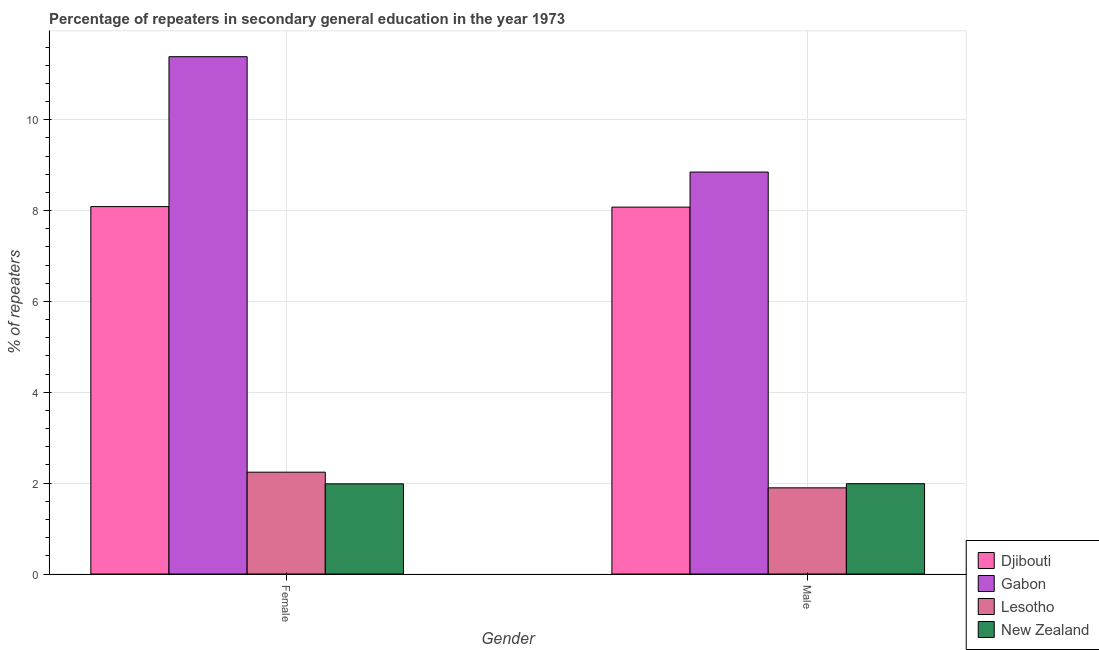How many groups of bars are there?
Keep it short and to the point. 2. Are the number of bars on each tick of the X-axis equal?
Make the answer very short. Yes. How many bars are there on the 1st tick from the left?
Your response must be concise. 4. What is the percentage of male repeaters in New Zealand?
Provide a short and direct response. 1.99. Across all countries, what is the maximum percentage of male repeaters?
Provide a succinct answer. 8.85. Across all countries, what is the minimum percentage of male repeaters?
Ensure brevity in your answer.  1.9. In which country was the percentage of female repeaters maximum?
Provide a short and direct response. Gabon. In which country was the percentage of female repeaters minimum?
Give a very brief answer. New Zealand. What is the total percentage of female repeaters in the graph?
Provide a succinct answer. 23.7. What is the difference between the percentage of female repeaters in New Zealand and that in Lesotho?
Give a very brief answer. -0.26. What is the difference between the percentage of male repeaters in New Zealand and the percentage of female repeaters in Djibouti?
Offer a terse response. -6.1. What is the average percentage of female repeaters per country?
Provide a short and direct response. 5.93. What is the difference between the percentage of female repeaters and percentage of male repeaters in Gabon?
Make the answer very short. 2.54. In how many countries, is the percentage of female repeaters greater than 2.8 %?
Provide a succinct answer. 2. What is the ratio of the percentage of male repeaters in Djibouti to that in Gabon?
Provide a short and direct response. 0.91. Is the percentage of female repeaters in Djibouti less than that in Gabon?
Your answer should be very brief. Yes. What does the 2nd bar from the left in Male represents?
Offer a very short reply. Gabon. What does the 4th bar from the right in Female represents?
Your response must be concise. Djibouti. Are all the bars in the graph horizontal?
Offer a very short reply. No. Does the graph contain any zero values?
Offer a very short reply. No. Where does the legend appear in the graph?
Your response must be concise. Bottom right. How are the legend labels stacked?
Your answer should be very brief. Vertical. What is the title of the graph?
Give a very brief answer. Percentage of repeaters in secondary general education in the year 1973. Does "Congo (Republic)" appear as one of the legend labels in the graph?
Make the answer very short. No. What is the label or title of the Y-axis?
Your answer should be compact. % of repeaters. What is the % of repeaters of Djibouti in Female?
Your answer should be compact. 8.09. What is the % of repeaters in Gabon in Female?
Your answer should be compact. 11.39. What is the % of repeaters of Lesotho in Female?
Offer a terse response. 2.24. What is the % of repeaters of New Zealand in Female?
Offer a terse response. 1.98. What is the % of repeaters of Djibouti in Male?
Offer a terse response. 8.08. What is the % of repeaters in Gabon in Male?
Your response must be concise. 8.85. What is the % of repeaters of Lesotho in Male?
Keep it short and to the point. 1.9. What is the % of repeaters of New Zealand in Male?
Make the answer very short. 1.99. Across all Gender, what is the maximum % of repeaters in Djibouti?
Make the answer very short. 8.09. Across all Gender, what is the maximum % of repeaters of Gabon?
Offer a terse response. 11.39. Across all Gender, what is the maximum % of repeaters in Lesotho?
Keep it short and to the point. 2.24. Across all Gender, what is the maximum % of repeaters of New Zealand?
Give a very brief answer. 1.99. Across all Gender, what is the minimum % of repeaters of Djibouti?
Your answer should be compact. 8.08. Across all Gender, what is the minimum % of repeaters of Gabon?
Ensure brevity in your answer.  8.85. Across all Gender, what is the minimum % of repeaters of Lesotho?
Ensure brevity in your answer.  1.9. Across all Gender, what is the minimum % of repeaters in New Zealand?
Provide a short and direct response. 1.98. What is the total % of repeaters of Djibouti in the graph?
Your response must be concise. 16.16. What is the total % of repeaters of Gabon in the graph?
Your answer should be compact. 20.24. What is the total % of repeaters in Lesotho in the graph?
Your response must be concise. 4.14. What is the total % of repeaters in New Zealand in the graph?
Your answer should be very brief. 3.97. What is the difference between the % of repeaters in Djibouti in Female and that in Male?
Offer a terse response. 0.01. What is the difference between the % of repeaters in Gabon in Female and that in Male?
Your answer should be compact. 2.54. What is the difference between the % of repeaters of Lesotho in Female and that in Male?
Offer a terse response. 0.34. What is the difference between the % of repeaters of New Zealand in Female and that in Male?
Your response must be concise. -0. What is the difference between the % of repeaters of Djibouti in Female and the % of repeaters of Gabon in Male?
Your answer should be compact. -0.76. What is the difference between the % of repeaters in Djibouti in Female and the % of repeaters in Lesotho in Male?
Provide a short and direct response. 6.19. What is the difference between the % of repeaters in Djibouti in Female and the % of repeaters in New Zealand in Male?
Your response must be concise. 6.1. What is the difference between the % of repeaters of Gabon in Female and the % of repeaters of Lesotho in Male?
Your answer should be compact. 9.49. What is the difference between the % of repeaters in Gabon in Female and the % of repeaters in New Zealand in Male?
Provide a short and direct response. 9.4. What is the difference between the % of repeaters of Lesotho in Female and the % of repeaters of New Zealand in Male?
Keep it short and to the point. 0.25. What is the average % of repeaters of Djibouti per Gender?
Offer a very short reply. 8.08. What is the average % of repeaters in Gabon per Gender?
Provide a short and direct response. 10.12. What is the average % of repeaters of Lesotho per Gender?
Your response must be concise. 2.07. What is the average % of repeaters in New Zealand per Gender?
Your response must be concise. 1.99. What is the difference between the % of repeaters of Djibouti and % of repeaters of Gabon in Female?
Provide a short and direct response. -3.3. What is the difference between the % of repeaters of Djibouti and % of repeaters of Lesotho in Female?
Make the answer very short. 5.85. What is the difference between the % of repeaters of Djibouti and % of repeaters of New Zealand in Female?
Give a very brief answer. 6.1. What is the difference between the % of repeaters of Gabon and % of repeaters of Lesotho in Female?
Keep it short and to the point. 9.15. What is the difference between the % of repeaters of Gabon and % of repeaters of New Zealand in Female?
Offer a terse response. 9.4. What is the difference between the % of repeaters in Lesotho and % of repeaters in New Zealand in Female?
Provide a succinct answer. 0.26. What is the difference between the % of repeaters of Djibouti and % of repeaters of Gabon in Male?
Your answer should be compact. -0.77. What is the difference between the % of repeaters of Djibouti and % of repeaters of Lesotho in Male?
Give a very brief answer. 6.18. What is the difference between the % of repeaters in Djibouti and % of repeaters in New Zealand in Male?
Your answer should be very brief. 6.09. What is the difference between the % of repeaters of Gabon and % of repeaters of Lesotho in Male?
Offer a very short reply. 6.95. What is the difference between the % of repeaters in Gabon and % of repeaters in New Zealand in Male?
Ensure brevity in your answer.  6.86. What is the difference between the % of repeaters in Lesotho and % of repeaters in New Zealand in Male?
Your answer should be very brief. -0.09. What is the ratio of the % of repeaters of Djibouti in Female to that in Male?
Ensure brevity in your answer.  1. What is the ratio of the % of repeaters in Gabon in Female to that in Male?
Keep it short and to the point. 1.29. What is the ratio of the % of repeaters of Lesotho in Female to that in Male?
Make the answer very short. 1.18. What is the difference between the highest and the second highest % of repeaters in Djibouti?
Offer a terse response. 0.01. What is the difference between the highest and the second highest % of repeaters in Gabon?
Offer a very short reply. 2.54. What is the difference between the highest and the second highest % of repeaters of Lesotho?
Your answer should be very brief. 0.34. What is the difference between the highest and the second highest % of repeaters in New Zealand?
Your response must be concise. 0. What is the difference between the highest and the lowest % of repeaters of Djibouti?
Offer a terse response. 0.01. What is the difference between the highest and the lowest % of repeaters of Gabon?
Offer a terse response. 2.54. What is the difference between the highest and the lowest % of repeaters in Lesotho?
Make the answer very short. 0.34. What is the difference between the highest and the lowest % of repeaters of New Zealand?
Give a very brief answer. 0. 